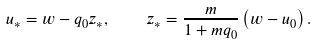Convert formula to latex. <formula><loc_0><loc_0><loc_500><loc_500>u _ { \ast } = w - q _ { 0 } z _ { \ast } , \quad z _ { \ast } = \frac { m } { 1 + m q _ { 0 } } \left ( w - u _ { 0 } \right ) .</formula> 